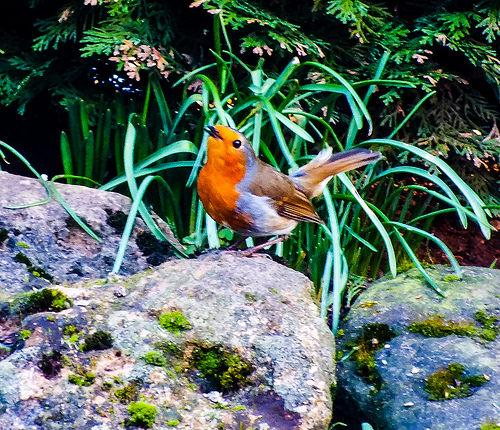<image>
Is the dove on the bush? No. The dove is not positioned on the bush. They may be near each other, but the dove is not supported by or resting on top of the bush. Is there a grass to the left of the bird? No. The grass is not to the left of the bird. From this viewpoint, they have a different horizontal relationship. 